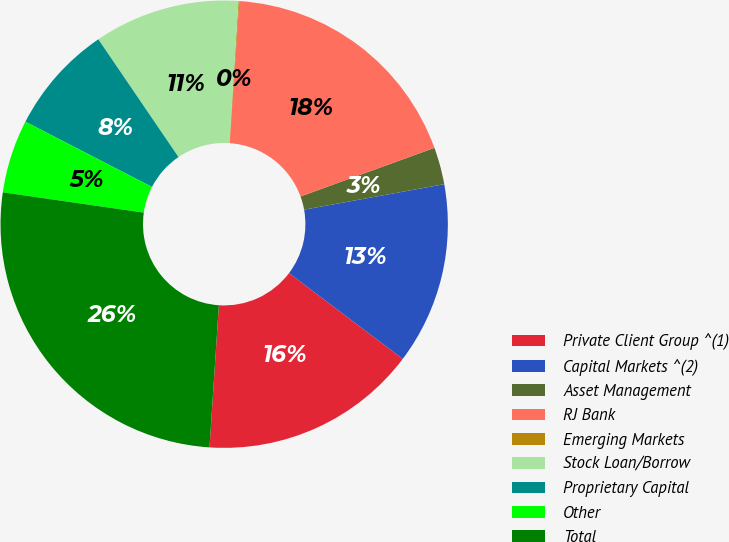Convert chart to OTSL. <chart><loc_0><loc_0><loc_500><loc_500><pie_chart><fcel>Private Client Group ^(1)<fcel>Capital Markets ^(2)<fcel>Asset Management<fcel>RJ Bank<fcel>Emerging Markets<fcel>Stock Loan/Borrow<fcel>Proprietary Capital<fcel>Other<fcel>Total<nl><fcel>15.76%<fcel>13.15%<fcel>2.68%<fcel>18.38%<fcel>0.06%<fcel>10.53%<fcel>7.91%<fcel>5.3%<fcel>26.23%<nl></chart> 